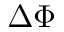Convert formula to latex. <formula><loc_0><loc_0><loc_500><loc_500>\Delta \Phi</formula> 